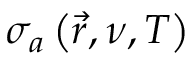Convert formula to latex. <formula><loc_0><loc_0><loc_500><loc_500>\sigma _ { a } \left ( \vec { r } , \nu , T \right )</formula> 